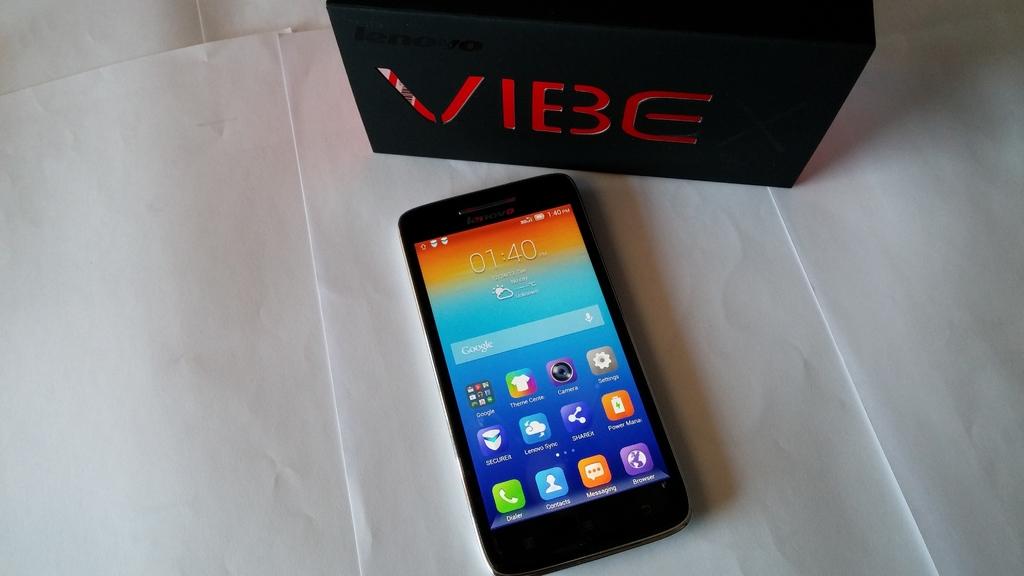What time is it on the phone?
Offer a very short reply. 01:40. What company made the phone?
Offer a very short reply. Vibe. 